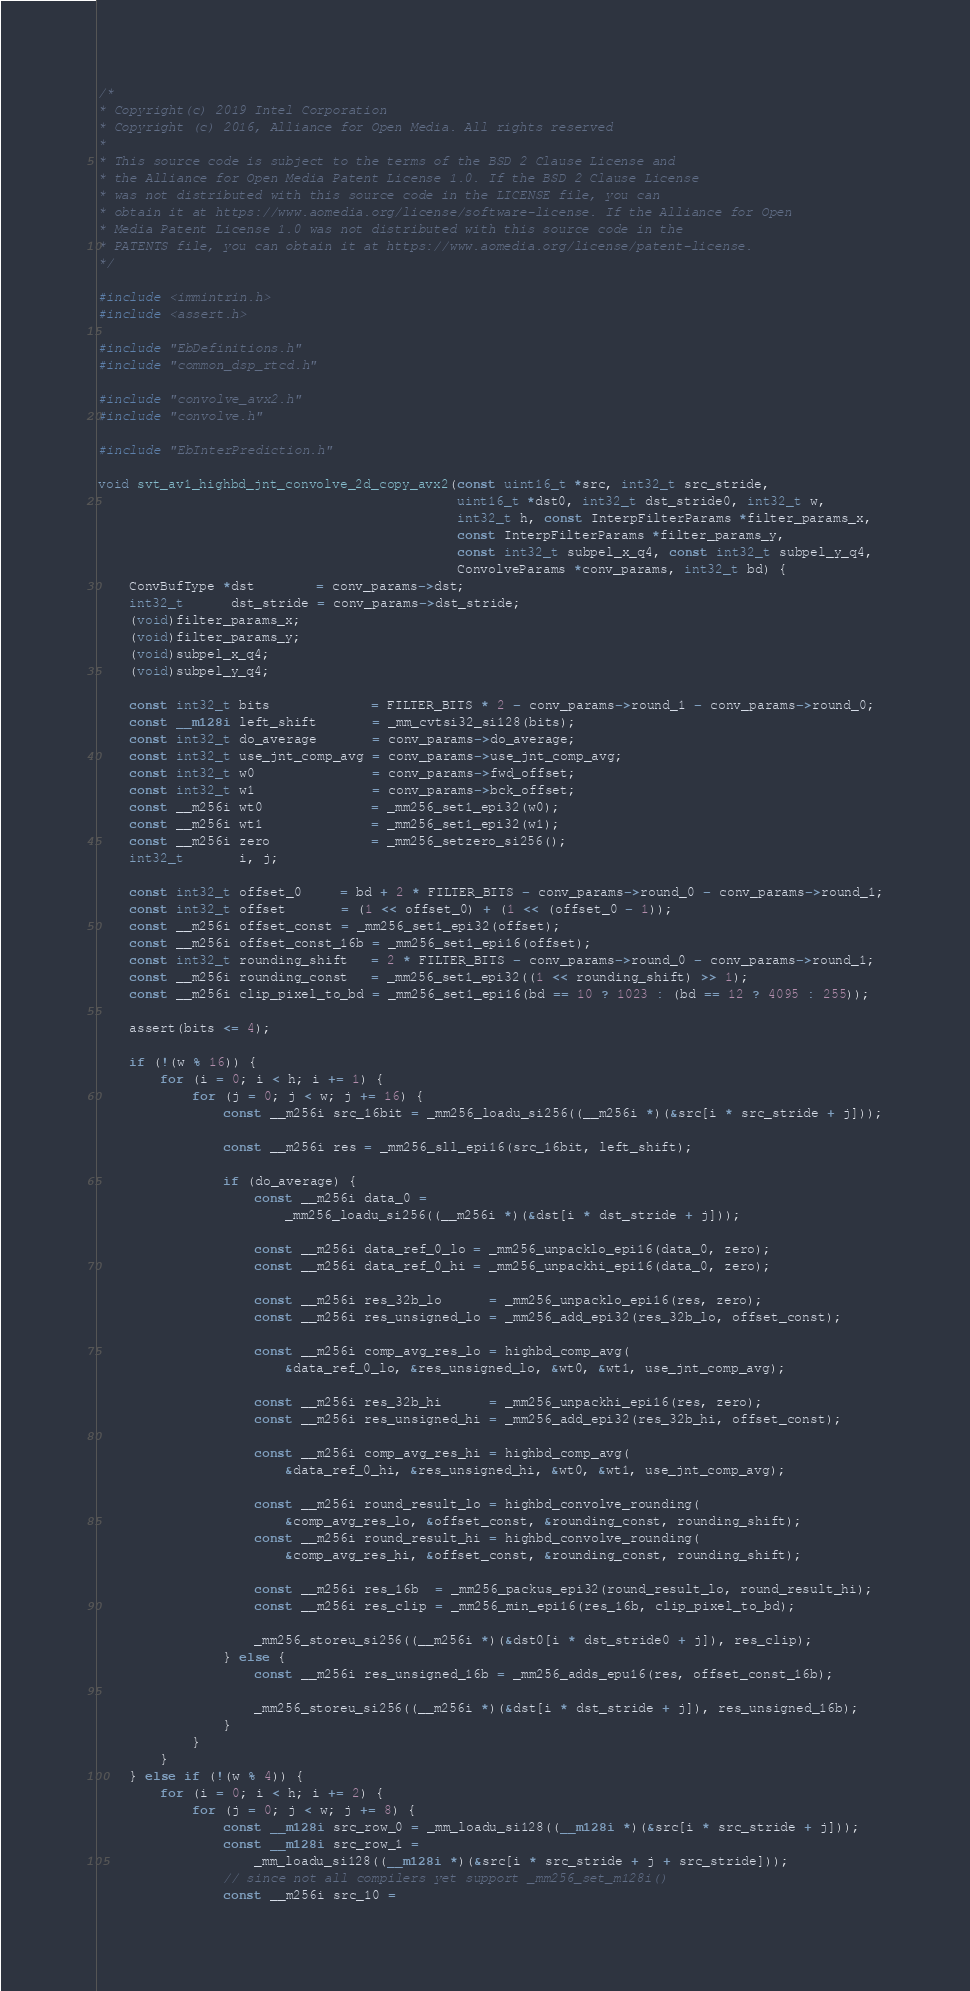<code> <loc_0><loc_0><loc_500><loc_500><_C_>/*
* Copyright(c) 2019 Intel Corporation
* Copyright (c) 2016, Alliance for Open Media. All rights reserved
*
* This source code is subject to the terms of the BSD 2 Clause License and
* the Alliance for Open Media Patent License 1.0. If the BSD 2 Clause License
* was not distributed with this source code in the LICENSE file, you can
* obtain it at https://www.aomedia.org/license/software-license. If the Alliance for Open
* Media Patent License 1.0 was not distributed with this source code in the
* PATENTS file, you can obtain it at https://www.aomedia.org/license/patent-license.
*/

#include <immintrin.h>
#include <assert.h>

#include "EbDefinitions.h"
#include "common_dsp_rtcd.h"

#include "convolve_avx2.h"
#include "convolve.h"

#include "EbInterPrediction.h"

void svt_av1_highbd_jnt_convolve_2d_copy_avx2(const uint16_t *src, int32_t src_stride,
                                              uint16_t *dst0, int32_t dst_stride0, int32_t w,
                                              int32_t h, const InterpFilterParams *filter_params_x,
                                              const InterpFilterParams *filter_params_y,
                                              const int32_t subpel_x_q4, const int32_t subpel_y_q4,
                                              ConvolveParams *conv_params, int32_t bd) {
    ConvBufType *dst        = conv_params->dst;
    int32_t      dst_stride = conv_params->dst_stride;
    (void)filter_params_x;
    (void)filter_params_y;
    (void)subpel_x_q4;
    (void)subpel_y_q4;

    const int32_t bits             = FILTER_BITS * 2 - conv_params->round_1 - conv_params->round_0;
    const __m128i left_shift       = _mm_cvtsi32_si128(bits);
    const int32_t do_average       = conv_params->do_average;
    const int32_t use_jnt_comp_avg = conv_params->use_jnt_comp_avg;
    const int32_t w0               = conv_params->fwd_offset;
    const int32_t w1               = conv_params->bck_offset;
    const __m256i wt0              = _mm256_set1_epi32(w0);
    const __m256i wt1              = _mm256_set1_epi32(w1);
    const __m256i zero             = _mm256_setzero_si256();
    int32_t       i, j;

    const int32_t offset_0     = bd + 2 * FILTER_BITS - conv_params->round_0 - conv_params->round_1;
    const int32_t offset       = (1 << offset_0) + (1 << (offset_0 - 1));
    const __m256i offset_const = _mm256_set1_epi32(offset);
    const __m256i offset_const_16b = _mm256_set1_epi16(offset);
    const int32_t rounding_shift   = 2 * FILTER_BITS - conv_params->round_0 - conv_params->round_1;
    const __m256i rounding_const   = _mm256_set1_epi32((1 << rounding_shift) >> 1);
    const __m256i clip_pixel_to_bd = _mm256_set1_epi16(bd == 10 ? 1023 : (bd == 12 ? 4095 : 255));

    assert(bits <= 4);

    if (!(w % 16)) {
        for (i = 0; i < h; i += 1) {
            for (j = 0; j < w; j += 16) {
                const __m256i src_16bit = _mm256_loadu_si256((__m256i *)(&src[i * src_stride + j]));

                const __m256i res = _mm256_sll_epi16(src_16bit, left_shift);

                if (do_average) {
                    const __m256i data_0 =
                        _mm256_loadu_si256((__m256i *)(&dst[i * dst_stride + j]));

                    const __m256i data_ref_0_lo = _mm256_unpacklo_epi16(data_0, zero);
                    const __m256i data_ref_0_hi = _mm256_unpackhi_epi16(data_0, zero);

                    const __m256i res_32b_lo      = _mm256_unpacklo_epi16(res, zero);
                    const __m256i res_unsigned_lo = _mm256_add_epi32(res_32b_lo, offset_const);

                    const __m256i comp_avg_res_lo = highbd_comp_avg(
                        &data_ref_0_lo, &res_unsigned_lo, &wt0, &wt1, use_jnt_comp_avg);

                    const __m256i res_32b_hi      = _mm256_unpackhi_epi16(res, zero);
                    const __m256i res_unsigned_hi = _mm256_add_epi32(res_32b_hi, offset_const);

                    const __m256i comp_avg_res_hi = highbd_comp_avg(
                        &data_ref_0_hi, &res_unsigned_hi, &wt0, &wt1, use_jnt_comp_avg);

                    const __m256i round_result_lo = highbd_convolve_rounding(
                        &comp_avg_res_lo, &offset_const, &rounding_const, rounding_shift);
                    const __m256i round_result_hi = highbd_convolve_rounding(
                        &comp_avg_res_hi, &offset_const, &rounding_const, rounding_shift);

                    const __m256i res_16b  = _mm256_packus_epi32(round_result_lo, round_result_hi);
                    const __m256i res_clip = _mm256_min_epi16(res_16b, clip_pixel_to_bd);

                    _mm256_storeu_si256((__m256i *)(&dst0[i * dst_stride0 + j]), res_clip);
                } else {
                    const __m256i res_unsigned_16b = _mm256_adds_epu16(res, offset_const_16b);

                    _mm256_storeu_si256((__m256i *)(&dst[i * dst_stride + j]), res_unsigned_16b);
                }
            }
        }
    } else if (!(w % 4)) {
        for (i = 0; i < h; i += 2) {
            for (j = 0; j < w; j += 8) {
                const __m128i src_row_0 = _mm_loadu_si128((__m128i *)(&src[i * src_stride + j]));
                const __m128i src_row_1 =
                    _mm_loadu_si128((__m128i *)(&src[i * src_stride + j + src_stride]));
                // since not all compilers yet support _mm256_set_m128i()
                const __m256i src_10 =</code> 